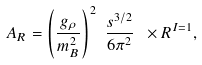Convert formula to latex. <formula><loc_0><loc_0><loc_500><loc_500>A _ { R } = { \left ( \frac { g _ { \rho } } { m _ { B } ^ { 2 } } \right ) } ^ { 2 } \ \frac { s ^ { 3 / 2 } } { 6 { \pi } ^ { 2 } } \ \times R ^ { I = 1 } ,</formula> 